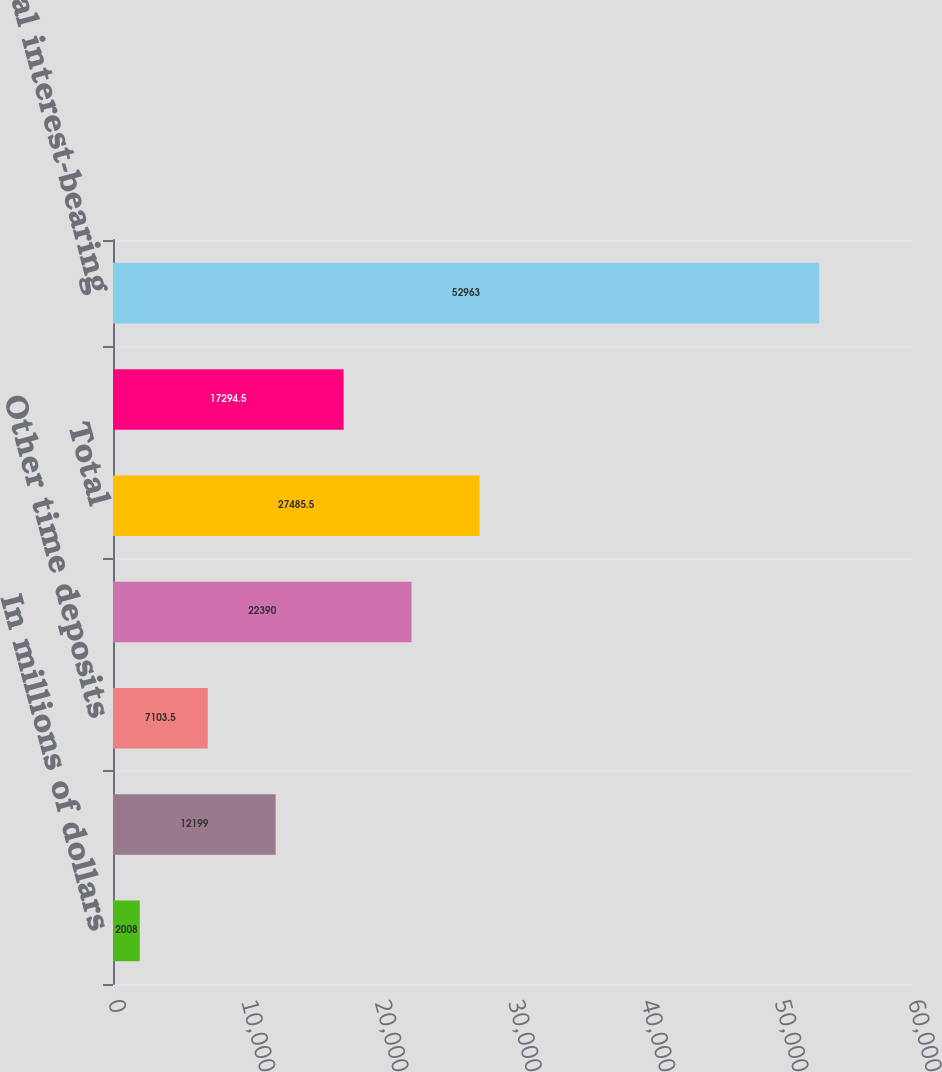Convert chart to OTSL. <chart><loc_0><loc_0><loc_500><loc_500><bar_chart><fcel>In millions of dollars<fcel>Savings deposits (5)<fcel>Other time deposits<fcel>In offices outside the US (6)<fcel>Total<fcel>In US offices<fcel>Total interest-bearing<nl><fcel>2008<fcel>12199<fcel>7103.5<fcel>22390<fcel>27485.5<fcel>17294.5<fcel>52963<nl></chart> 